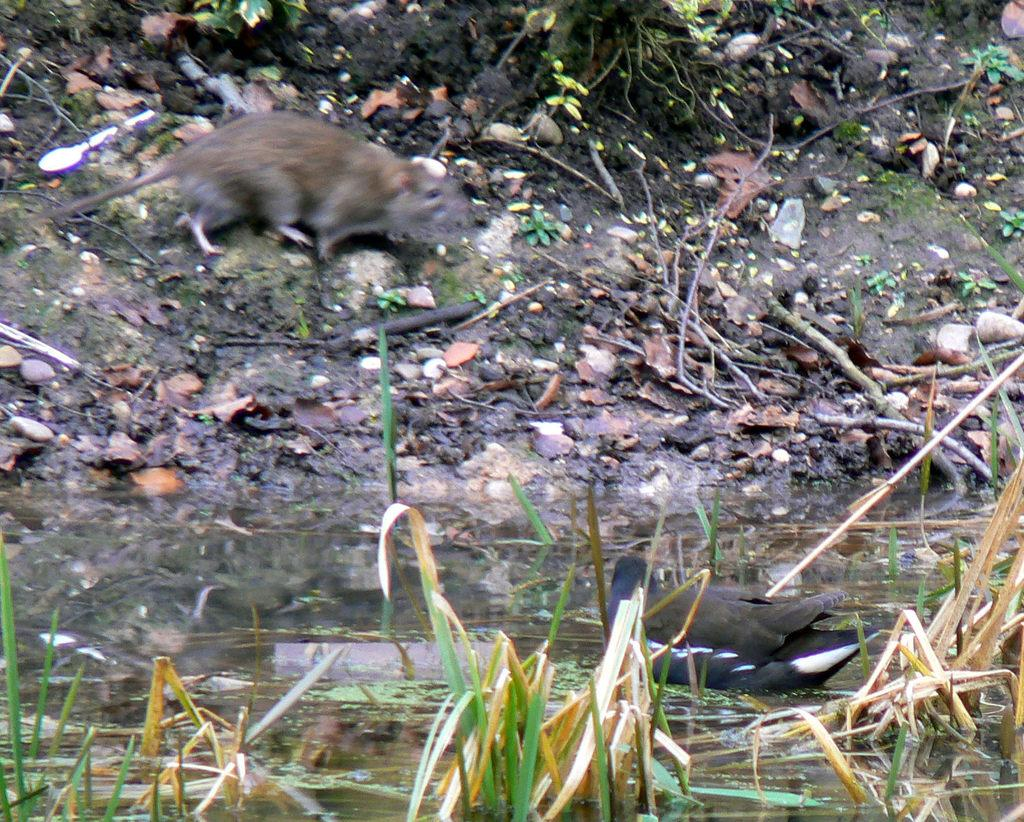What type of animal can be seen in the image? There is a rat in the image. What natural element is visible in the image? Water and grass are visible in the image. What other living creature can be seen in the image? There is a bird in the image. What type of plant material is present in the image? Dried leaves are present in the image. What utensil can be seen in the image? There is a spoon in the image. What type of geological feature is visible in the image? Rocks are visible in the image. What type of plant material is used as a structural element in the image? Sticks are present in the image. What type of activity is the rat participating in with the base and detail in the image? There is no activity, base, or detail involving the rat in the image. 